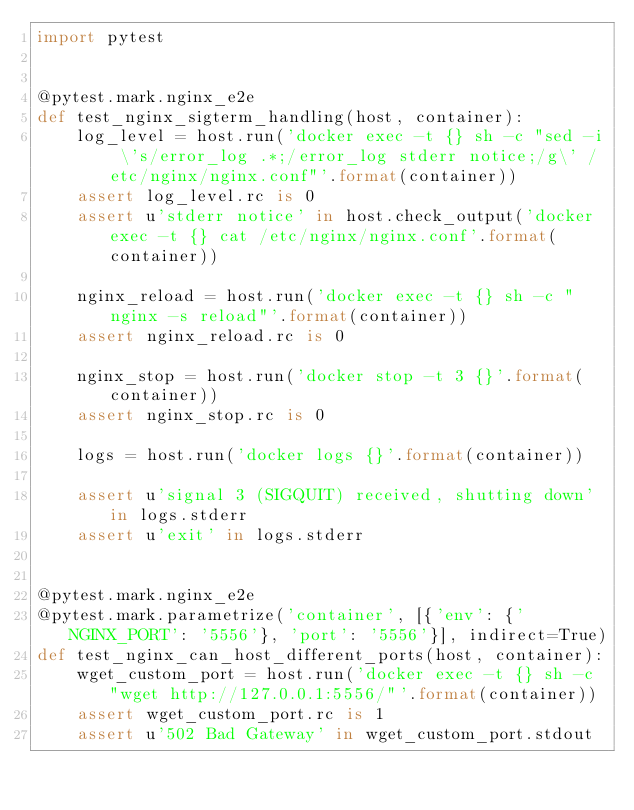Convert code to text. <code><loc_0><loc_0><loc_500><loc_500><_Python_>import pytest


@pytest.mark.nginx_e2e
def test_nginx_sigterm_handling(host, container):
    log_level = host.run('docker exec -t {} sh -c "sed -i \'s/error_log .*;/error_log stderr notice;/g\' /etc/nginx/nginx.conf"'.format(container))
    assert log_level.rc is 0
    assert u'stderr notice' in host.check_output('docker exec -t {} cat /etc/nginx/nginx.conf'.format(container))

    nginx_reload = host.run('docker exec -t {} sh -c "nginx -s reload"'.format(container))
    assert nginx_reload.rc is 0

    nginx_stop = host.run('docker stop -t 3 {}'.format(container))
    assert nginx_stop.rc is 0

    logs = host.run('docker logs {}'.format(container))

    assert u'signal 3 (SIGQUIT) received, shutting down' in logs.stderr
    assert u'exit' in logs.stderr


@pytest.mark.nginx_e2e
@pytest.mark.parametrize('container', [{'env': {'NGINX_PORT': '5556'}, 'port': '5556'}], indirect=True)
def test_nginx_can_host_different_ports(host, container):
    wget_custom_port = host.run('docker exec -t {} sh -c "wget http://127.0.0.1:5556/"'.format(container))
    assert wget_custom_port.rc is 1
    assert u'502 Bad Gateway' in wget_custom_port.stdout
</code> 